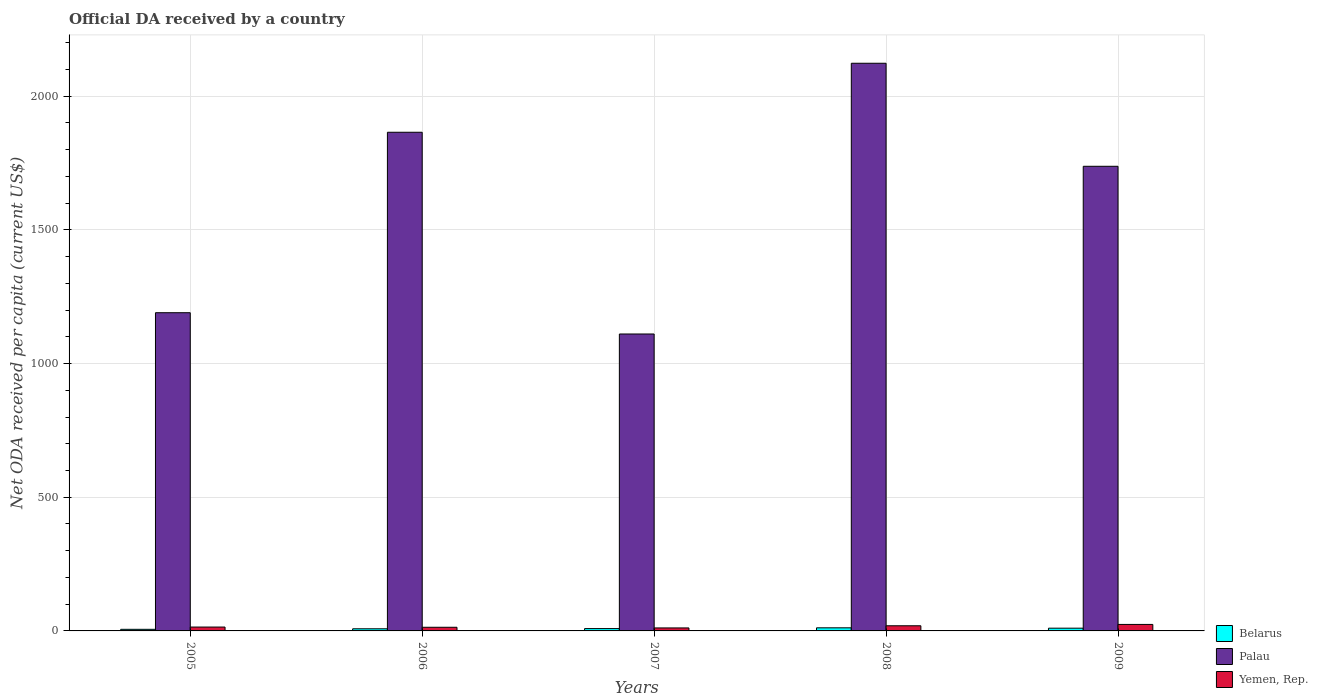How many different coloured bars are there?
Offer a terse response. 3. In how many cases, is the number of bars for a given year not equal to the number of legend labels?
Keep it short and to the point. 0. What is the ODA received in in Yemen, Rep. in 2009?
Provide a short and direct response. 24.3. Across all years, what is the maximum ODA received in in Palau?
Keep it short and to the point. 2122.91. Across all years, what is the minimum ODA received in in Palau?
Your answer should be very brief. 1110.45. In which year was the ODA received in in Belarus maximum?
Give a very brief answer. 2008. What is the total ODA received in in Belarus in the graph?
Keep it short and to the point. 44.57. What is the difference between the ODA received in in Palau in 2005 and that in 2007?
Your answer should be very brief. 79.59. What is the difference between the ODA received in in Yemen, Rep. in 2008 and the ODA received in in Palau in 2009?
Your answer should be very brief. -1718.37. What is the average ODA received in in Yemen, Rep. per year?
Make the answer very short. 16.56. In the year 2008, what is the difference between the ODA received in in Yemen, Rep. and ODA received in in Belarus?
Provide a succinct answer. 7.66. What is the ratio of the ODA received in in Palau in 2005 to that in 2006?
Your answer should be very brief. 0.64. Is the ODA received in in Palau in 2008 less than that in 2009?
Provide a succinct answer. No. What is the difference between the highest and the second highest ODA received in in Belarus?
Provide a short and direct response. 1.32. What is the difference between the highest and the lowest ODA received in in Belarus?
Give a very brief answer. 5.61. Is the sum of the ODA received in in Belarus in 2005 and 2007 greater than the maximum ODA received in in Palau across all years?
Your answer should be compact. No. What does the 1st bar from the left in 2009 represents?
Your answer should be compact. Belarus. What does the 2nd bar from the right in 2009 represents?
Give a very brief answer. Palau. Are all the bars in the graph horizontal?
Make the answer very short. No. What is the difference between two consecutive major ticks on the Y-axis?
Your answer should be very brief. 500. Does the graph contain any zero values?
Your answer should be compact. No. How many legend labels are there?
Your response must be concise. 3. How are the legend labels stacked?
Your answer should be compact. Vertical. What is the title of the graph?
Offer a terse response. Official DA received by a country. What is the label or title of the X-axis?
Offer a terse response. Years. What is the label or title of the Y-axis?
Provide a succinct answer. Net ODA received per capita (current US$). What is the Net ODA received per capita (current US$) of Belarus in 2005?
Your answer should be compact. 5.98. What is the Net ODA received per capita (current US$) of Palau in 2005?
Make the answer very short. 1190.03. What is the Net ODA received per capita (current US$) in Yemen, Rep. in 2005?
Your answer should be very brief. 14.46. What is the Net ODA received per capita (current US$) in Belarus in 2006?
Provide a short and direct response. 7.97. What is the Net ODA received per capita (current US$) in Palau in 2006?
Give a very brief answer. 1864.88. What is the Net ODA received per capita (current US$) in Yemen, Rep. in 2006?
Ensure brevity in your answer.  13.63. What is the Net ODA received per capita (current US$) in Belarus in 2007?
Offer a terse response. 8.76. What is the Net ODA received per capita (current US$) in Palau in 2007?
Your answer should be very brief. 1110.45. What is the Net ODA received per capita (current US$) of Yemen, Rep. in 2007?
Provide a short and direct response. 11.18. What is the Net ODA received per capita (current US$) of Belarus in 2008?
Offer a terse response. 11.59. What is the Net ODA received per capita (current US$) in Palau in 2008?
Your answer should be very brief. 2122.91. What is the Net ODA received per capita (current US$) in Yemen, Rep. in 2008?
Offer a terse response. 19.25. What is the Net ODA received per capita (current US$) of Belarus in 2009?
Give a very brief answer. 10.27. What is the Net ODA received per capita (current US$) of Palau in 2009?
Offer a terse response. 1737.61. What is the Net ODA received per capita (current US$) in Yemen, Rep. in 2009?
Give a very brief answer. 24.3. Across all years, what is the maximum Net ODA received per capita (current US$) of Belarus?
Provide a succinct answer. 11.59. Across all years, what is the maximum Net ODA received per capita (current US$) in Palau?
Provide a succinct answer. 2122.91. Across all years, what is the maximum Net ODA received per capita (current US$) in Yemen, Rep.?
Offer a terse response. 24.3. Across all years, what is the minimum Net ODA received per capita (current US$) of Belarus?
Give a very brief answer. 5.98. Across all years, what is the minimum Net ODA received per capita (current US$) of Palau?
Provide a short and direct response. 1110.45. Across all years, what is the minimum Net ODA received per capita (current US$) of Yemen, Rep.?
Ensure brevity in your answer.  11.18. What is the total Net ODA received per capita (current US$) of Belarus in the graph?
Your answer should be compact. 44.57. What is the total Net ODA received per capita (current US$) of Palau in the graph?
Ensure brevity in your answer.  8025.88. What is the total Net ODA received per capita (current US$) of Yemen, Rep. in the graph?
Provide a succinct answer. 82.81. What is the difference between the Net ODA received per capita (current US$) of Belarus in 2005 and that in 2006?
Provide a short and direct response. -1.98. What is the difference between the Net ODA received per capita (current US$) in Palau in 2005 and that in 2006?
Offer a terse response. -674.85. What is the difference between the Net ODA received per capita (current US$) in Yemen, Rep. in 2005 and that in 2006?
Offer a terse response. 0.84. What is the difference between the Net ODA received per capita (current US$) of Belarus in 2005 and that in 2007?
Provide a short and direct response. -2.78. What is the difference between the Net ODA received per capita (current US$) of Palau in 2005 and that in 2007?
Ensure brevity in your answer.  79.59. What is the difference between the Net ODA received per capita (current US$) of Yemen, Rep. in 2005 and that in 2007?
Offer a terse response. 3.28. What is the difference between the Net ODA received per capita (current US$) of Belarus in 2005 and that in 2008?
Your answer should be very brief. -5.61. What is the difference between the Net ODA received per capita (current US$) in Palau in 2005 and that in 2008?
Keep it short and to the point. -932.87. What is the difference between the Net ODA received per capita (current US$) in Yemen, Rep. in 2005 and that in 2008?
Give a very brief answer. -4.78. What is the difference between the Net ODA received per capita (current US$) in Belarus in 2005 and that in 2009?
Ensure brevity in your answer.  -4.29. What is the difference between the Net ODA received per capita (current US$) in Palau in 2005 and that in 2009?
Ensure brevity in your answer.  -547.58. What is the difference between the Net ODA received per capita (current US$) of Yemen, Rep. in 2005 and that in 2009?
Provide a succinct answer. -9.84. What is the difference between the Net ODA received per capita (current US$) of Belarus in 2006 and that in 2007?
Give a very brief answer. -0.79. What is the difference between the Net ODA received per capita (current US$) in Palau in 2006 and that in 2007?
Your answer should be compact. 754.43. What is the difference between the Net ODA received per capita (current US$) of Yemen, Rep. in 2006 and that in 2007?
Ensure brevity in your answer.  2.45. What is the difference between the Net ODA received per capita (current US$) of Belarus in 2006 and that in 2008?
Give a very brief answer. -3.62. What is the difference between the Net ODA received per capita (current US$) of Palau in 2006 and that in 2008?
Offer a very short reply. -258.02. What is the difference between the Net ODA received per capita (current US$) in Yemen, Rep. in 2006 and that in 2008?
Your answer should be very brief. -5.62. What is the difference between the Net ODA received per capita (current US$) of Belarus in 2006 and that in 2009?
Provide a succinct answer. -2.3. What is the difference between the Net ODA received per capita (current US$) in Palau in 2006 and that in 2009?
Ensure brevity in your answer.  127.27. What is the difference between the Net ODA received per capita (current US$) in Yemen, Rep. in 2006 and that in 2009?
Give a very brief answer. -10.68. What is the difference between the Net ODA received per capita (current US$) of Belarus in 2007 and that in 2008?
Provide a short and direct response. -2.83. What is the difference between the Net ODA received per capita (current US$) in Palau in 2007 and that in 2008?
Offer a very short reply. -1012.46. What is the difference between the Net ODA received per capita (current US$) in Yemen, Rep. in 2007 and that in 2008?
Your answer should be very brief. -8.07. What is the difference between the Net ODA received per capita (current US$) in Belarus in 2007 and that in 2009?
Give a very brief answer. -1.51. What is the difference between the Net ODA received per capita (current US$) of Palau in 2007 and that in 2009?
Keep it short and to the point. -627.16. What is the difference between the Net ODA received per capita (current US$) of Yemen, Rep. in 2007 and that in 2009?
Provide a succinct answer. -13.13. What is the difference between the Net ODA received per capita (current US$) of Belarus in 2008 and that in 2009?
Your answer should be compact. 1.32. What is the difference between the Net ODA received per capita (current US$) in Palau in 2008 and that in 2009?
Give a very brief answer. 385.29. What is the difference between the Net ODA received per capita (current US$) in Yemen, Rep. in 2008 and that in 2009?
Your answer should be compact. -5.06. What is the difference between the Net ODA received per capita (current US$) in Belarus in 2005 and the Net ODA received per capita (current US$) in Palau in 2006?
Provide a short and direct response. -1858.9. What is the difference between the Net ODA received per capita (current US$) of Belarus in 2005 and the Net ODA received per capita (current US$) of Yemen, Rep. in 2006?
Your answer should be very brief. -7.64. What is the difference between the Net ODA received per capita (current US$) in Palau in 2005 and the Net ODA received per capita (current US$) in Yemen, Rep. in 2006?
Keep it short and to the point. 1176.41. What is the difference between the Net ODA received per capita (current US$) of Belarus in 2005 and the Net ODA received per capita (current US$) of Palau in 2007?
Your response must be concise. -1104.47. What is the difference between the Net ODA received per capita (current US$) in Belarus in 2005 and the Net ODA received per capita (current US$) in Yemen, Rep. in 2007?
Make the answer very short. -5.19. What is the difference between the Net ODA received per capita (current US$) in Palau in 2005 and the Net ODA received per capita (current US$) in Yemen, Rep. in 2007?
Provide a succinct answer. 1178.86. What is the difference between the Net ODA received per capita (current US$) of Belarus in 2005 and the Net ODA received per capita (current US$) of Palau in 2008?
Your response must be concise. -2116.92. What is the difference between the Net ODA received per capita (current US$) of Belarus in 2005 and the Net ODA received per capita (current US$) of Yemen, Rep. in 2008?
Your answer should be compact. -13.26. What is the difference between the Net ODA received per capita (current US$) of Palau in 2005 and the Net ODA received per capita (current US$) of Yemen, Rep. in 2008?
Keep it short and to the point. 1170.79. What is the difference between the Net ODA received per capita (current US$) of Belarus in 2005 and the Net ODA received per capita (current US$) of Palau in 2009?
Your answer should be compact. -1731.63. What is the difference between the Net ODA received per capita (current US$) in Belarus in 2005 and the Net ODA received per capita (current US$) in Yemen, Rep. in 2009?
Make the answer very short. -18.32. What is the difference between the Net ODA received per capita (current US$) in Palau in 2005 and the Net ODA received per capita (current US$) in Yemen, Rep. in 2009?
Offer a very short reply. 1165.73. What is the difference between the Net ODA received per capita (current US$) of Belarus in 2006 and the Net ODA received per capita (current US$) of Palau in 2007?
Provide a short and direct response. -1102.48. What is the difference between the Net ODA received per capita (current US$) of Belarus in 2006 and the Net ODA received per capita (current US$) of Yemen, Rep. in 2007?
Ensure brevity in your answer.  -3.21. What is the difference between the Net ODA received per capita (current US$) in Palau in 2006 and the Net ODA received per capita (current US$) in Yemen, Rep. in 2007?
Offer a very short reply. 1853.7. What is the difference between the Net ODA received per capita (current US$) in Belarus in 2006 and the Net ODA received per capita (current US$) in Palau in 2008?
Your answer should be very brief. -2114.94. What is the difference between the Net ODA received per capita (current US$) in Belarus in 2006 and the Net ODA received per capita (current US$) in Yemen, Rep. in 2008?
Make the answer very short. -11.28. What is the difference between the Net ODA received per capita (current US$) in Palau in 2006 and the Net ODA received per capita (current US$) in Yemen, Rep. in 2008?
Your answer should be compact. 1845.64. What is the difference between the Net ODA received per capita (current US$) in Belarus in 2006 and the Net ODA received per capita (current US$) in Palau in 2009?
Provide a short and direct response. -1729.65. What is the difference between the Net ODA received per capita (current US$) in Belarus in 2006 and the Net ODA received per capita (current US$) in Yemen, Rep. in 2009?
Your answer should be compact. -16.34. What is the difference between the Net ODA received per capita (current US$) in Palau in 2006 and the Net ODA received per capita (current US$) in Yemen, Rep. in 2009?
Offer a terse response. 1840.58. What is the difference between the Net ODA received per capita (current US$) of Belarus in 2007 and the Net ODA received per capita (current US$) of Palau in 2008?
Your answer should be compact. -2114.14. What is the difference between the Net ODA received per capita (current US$) of Belarus in 2007 and the Net ODA received per capita (current US$) of Yemen, Rep. in 2008?
Offer a very short reply. -10.48. What is the difference between the Net ODA received per capita (current US$) in Palau in 2007 and the Net ODA received per capita (current US$) in Yemen, Rep. in 2008?
Offer a terse response. 1091.2. What is the difference between the Net ODA received per capita (current US$) of Belarus in 2007 and the Net ODA received per capita (current US$) of Palau in 2009?
Provide a succinct answer. -1728.85. What is the difference between the Net ODA received per capita (current US$) of Belarus in 2007 and the Net ODA received per capita (current US$) of Yemen, Rep. in 2009?
Ensure brevity in your answer.  -15.54. What is the difference between the Net ODA received per capita (current US$) in Palau in 2007 and the Net ODA received per capita (current US$) in Yemen, Rep. in 2009?
Make the answer very short. 1086.15. What is the difference between the Net ODA received per capita (current US$) in Belarus in 2008 and the Net ODA received per capita (current US$) in Palau in 2009?
Ensure brevity in your answer.  -1726.02. What is the difference between the Net ODA received per capita (current US$) of Belarus in 2008 and the Net ODA received per capita (current US$) of Yemen, Rep. in 2009?
Give a very brief answer. -12.71. What is the difference between the Net ODA received per capita (current US$) of Palau in 2008 and the Net ODA received per capita (current US$) of Yemen, Rep. in 2009?
Make the answer very short. 2098.6. What is the average Net ODA received per capita (current US$) in Belarus per year?
Offer a terse response. 8.91. What is the average Net ODA received per capita (current US$) of Palau per year?
Your response must be concise. 1605.18. What is the average Net ODA received per capita (current US$) in Yemen, Rep. per year?
Ensure brevity in your answer.  16.56. In the year 2005, what is the difference between the Net ODA received per capita (current US$) of Belarus and Net ODA received per capita (current US$) of Palau?
Your answer should be very brief. -1184.05. In the year 2005, what is the difference between the Net ODA received per capita (current US$) of Belarus and Net ODA received per capita (current US$) of Yemen, Rep.?
Keep it short and to the point. -8.48. In the year 2005, what is the difference between the Net ODA received per capita (current US$) of Palau and Net ODA received per capita (current US$) of Yemen, Rep.?
Keep it short and to the point. 1175.57. In the year 2006, what is the difference between the Net ODA received per capita (current US$) of Belarus and Net ODA received per capita (current US$) of Palau?
Keep it short and to the point. -1856.91. In the year 2006, what is the difference between the Net ODA received per capita (current US$) of Belarus and Net ODA received per capita (current US$) of Yemen, Rep.?
Make the answer very short. -5.66. In the year 2006, what is the difference between the Net ODA received per capita (current US$) in Palau and Net ODA received per capita (current US$) in Yemen, Rep.?
Your answer should be very brief. 1851.26. In the year 2007, what is the difference between the Net ODA received per capita (current US$) in Belarus and Net ODA received per capita (current US$) in Palau?
Keep it short and to the point. -1101.69. In the year 2007, what is the difference between the Net ODA received per capita (current US$) of Belarus and Net ODA received per capita (current US$) of Yemen, Rep.?
Ensure brevity in your answer.  -2.42. In the year 2007, what is the difference between the Net ODA received per capita (current US$) in Palau and Net ODA received per capita (current US$) in Yemen, Rep.?
Your answer should be very brief. 1099.27. In the year 2008, what is the difference between the Net ODA received per capita (current US$) of Belarus and Net ODA received per capita (current US$) of Palau?
Provide a succinct answer. -2111.32. In the year 2008, what is the difference between the Net ODA received per capita (current US$) of Belarus and Net ODA received per capita (current US$) of Yemen, Rep.?
Offer a terse response. -7.66. In the year 2008, what is the difference between the Net ODA received per capita (current US$) in Palau and Net ODA received per capita (current US$) in Yemen, Rep.?
Provide a succinct answer. 2103.66. In the year 2009, what is the difference between the Net ODA received per capita (current US$) of Belarus and Net ODA received per capita (current US$) of Palau?
Your response must be concise. -1727.34. In the year 2009, what is the difference between the Net ODA received per capita (current US$) of Belarus and Net ODA received per capita (current US$) of Yemen, Rep.?
Offer a very short reply. -14.03. In the year 2009, what is the difference between the Net ODA received per capita (current US$) of Palau and Net ODA received per capita (current US$) of Yemen, Rep.?
Your answer should be very brief. 1713.31. What is the ratio of the Net ODA received per capita (current US$) of Belarus in 2005 to that in 2006?
Provide a short and direct response. 0.75. What is the ratio of the Net ODA received per capita (current US$) in Palau in 2005 to that in 2006?
Ensure brevity in your answer.  0.64. What is the ratio of the Net ODA received per capita (current US$) of Yemen, Rep. in 2005 to that in 2006?
Offer a very short reply. 1.06. What is the ratio of the Net ODA received per capita (current US$) in Belarus in 2005 to that in 2007?
Your response must be concise. 0.68. What is the ratio of the Net ODA received per capita (current US$) of Palau in 2005 to that in 2007?
Give a very brief answer. 1.07. What is the ratio of the Net ODA received per capita (current US$) of Yemen, Rep. in 2005 to that in 2007?
Provide a short and direct response. 1.29. What is the ratio of the Net ODA received per capita (current US$) in Belarus in 2005 to that in 2008?
Provide a succinct answer. 0.52. What is the ratio of the Net ODA received per capita (current US$) in Palau in 2005 to that in 2008?
Give a very brief answer. 0.56. What is the ratio of the Net ODA received per capita (current US$) of Yemen, Rep. in 2005 to that in 2008?
Offer a terse response. 0.75. What is the ratio of the Net ODA received per capita (current US$) of Belarus in 2005 to that in 2009?
Provide a short and direct response. 0.58. What is the ratio of the Net ODA received per capita (current US$) of Palau in 2005 to that in 2009?
Keep it short and to the point. 0.68. What is the ratio of the Net ODA received per capita (current US$) of Yemen, Rep. in 2005 to that in 2009?
Give a very brief answer. 0.6. What is the ratio of the Net ODA received per capita (current US$) in Belarus in 2006 to that in 2007?
Keep it short and to the point. 0.91. What is the ratio of the Net ODA received per capita (current US$) in Palau in 2006 to that in 2007?
Offer a terse response. 1.68. What is the ratio of the Net ODA received per capita (current US$) of Yemen, Rep. in 2006 to that in 2007?
Offer a terse response. 1.22. What is the ratio of the Net ODA received per capita (current US$) in Belarus in 2006 to that in 2008?
Your answer should be very brief. 0.69. What is the ratio of the Net ODA received per capita (current US$) of Palau in 2006 to that in 2008?
Provide a short and direct response. 0.88. What is the ratio of the Net ODA received per capita (current US$) in Yemen, Rep. in 2006 to that in 2008?
Make the answer very short. 0.71. What is the ratio of the Net ODA received per capita (current US$) in Belarus in 2006 to that in 2009?
Ensure brevity in your answer.  0.78. What is the ratio of the Net ODA received per capita (current US$) in Palau in 2006 to that in 2009?
Provide a succinct answer. 1.07. What is the ratio of the Net ODA received per capita (current US$) in Yemen, Rep. in 2006 to that in 2009?
Offer a terse response. 0.56. What is the ratio of the Net ODA received per capita (current US$) in Belarus in 2007 to that in 2008?
Offer a very short reply. 0.76. What is the ratio of the Net ODA received per capita (current US$) in Palau in 2007 to that in 2008?
Offer a very short reply. 0.52. What is the ratio of the Net ODA received per capita (current US$) of Yemen, Rep. in 2007 to that in 2008?
Offer a very short reply. 0.58. What is the ratio of the Net ODA received per capita (current US$) of Belarus in 2007 to that in 2009?
Your response must be concise. 0.85. What is the ratio of the Net ODA received per capita (current US$) of Palau in 2007 to that in 2009?
Keep it short and to the point. 0.64. What is the ratio of the Net ODA received per capita (current US$) in Yemen, Rep. in 2007 to that in 2009?
Your response must be concise. 0.46. What is the ratio of the Net ODA received per capita (current US$) in Belarus in 2008 to that in 2009?
Give a very brief answer. 1.13. What is the ratio of the Net ODA received per capita (current US$) of Palau in 2008 to that in 2009?
Provide a short and direct response. 1.22. What is the ratio of the Net ODA received per capita (current US$) of Yemen, Rep. in 2008 to that in 2009?
Give a very brief answer. 0.79. What is the difference between the highest and the second highest Net ODA received per capita (current US$) in Belarus?
Make the answer very short. 1.32. What is the difference between the highest and the second highest Net ODA received per capita (current US$) in Palau?
Your answer should be compact. 258.02. What is the difference between the highest and the second highest Net ODA received per capita (current US$) of Yemen, Rep.?
Keep it short and to the point. 5.06. What is the difference between the highest and the lowest Net ODA received per capita (current US$) in Belarus?
Offer a very short reply. 5.61. What is the difference between the highest and the lowest Net ODA received per capita (current US$) of Palau?
Give a very brief answer. 1012.46. What is the difference between the highest and the lowest Net ODA received per capita (current US$) in Yemen, Rep.?
Offer a very short reply. 13.13. 